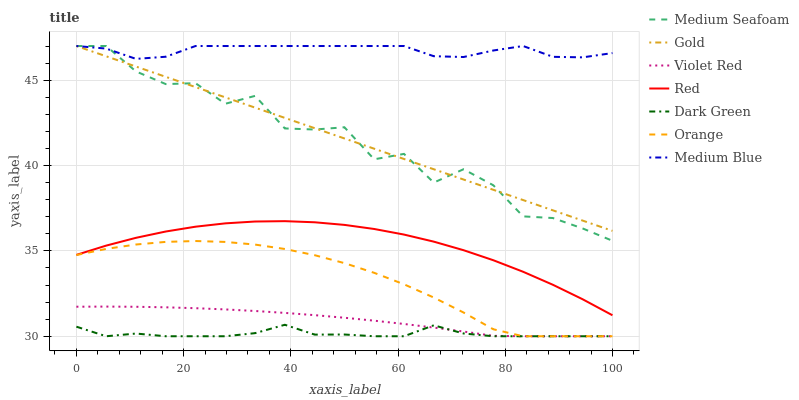Does Dark Green have the minimum area under the curve?
Answer yes or no. Yes. Does Medium Blue have the maximum area under the curve?
Answer yes or no. Yes. Does Gold have the minimum area under the curve?
Answer yes or no. No. Does Gold have the maximum area under the curve?
Answer yes or no. No. Is Gold the smoothest?
Answer yes or no. Yes. Is Medium Seafoam the roughest?
Answer yes or no. Yes. Is Medium Blue the smoothest?
Answer yes or no. No. Is Medium Blue the roughest?
Answer yes or no. No. Does Violet Red have the lowest value?
Answer yes or no. Yes. Does Gold have the lowest value?
Answer yes or no. No. Does Medium Seafoam have the highest value?
Answer yes or no. Yes. Does Orange have the highest value?
Answer yes or no. No. Is Dark Green less than Medium Blue?
Answer yes or no. Yes. Is Medium Blue greater than Red?
Answer yes or no. Yes. Does Violet Red intersect Orange?
Answer yes or no. Yes. Is Violet Red less than Orange?
Answer yes or no. No. Is Violet Red greater than Orange?
Answer yes or no. No. Does Dark Green intersect Medium Blue?
Answer yes or no. No. 